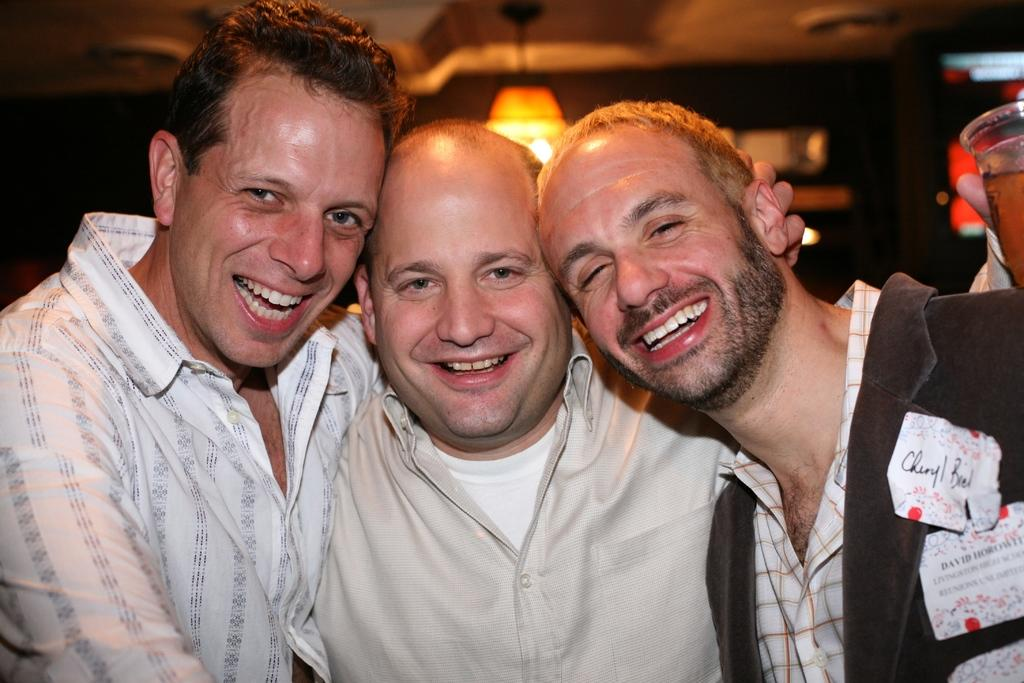How many people are in the image? There are three men in the image. What are the men doing in the image? The men are standing and holding each other, and they are laughing. What can be seen in the background of the image? There is a ceiling and a light visible in the background of the image. What type of flowers can be seen growing on the men's heads in the image? There are no flowers present in the image; the men are not depicted with flowers on their heads. 